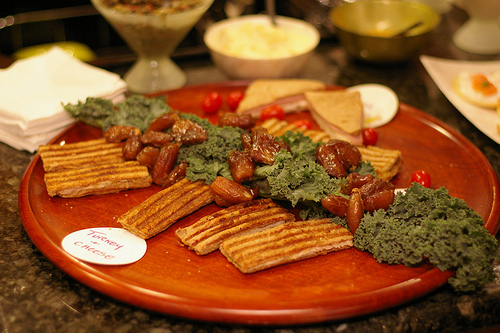<image>
Is there a green bowl to the right of the food label? Yes. From this viewpoint, the green bowl is positioned to the right side relative to the food label. 